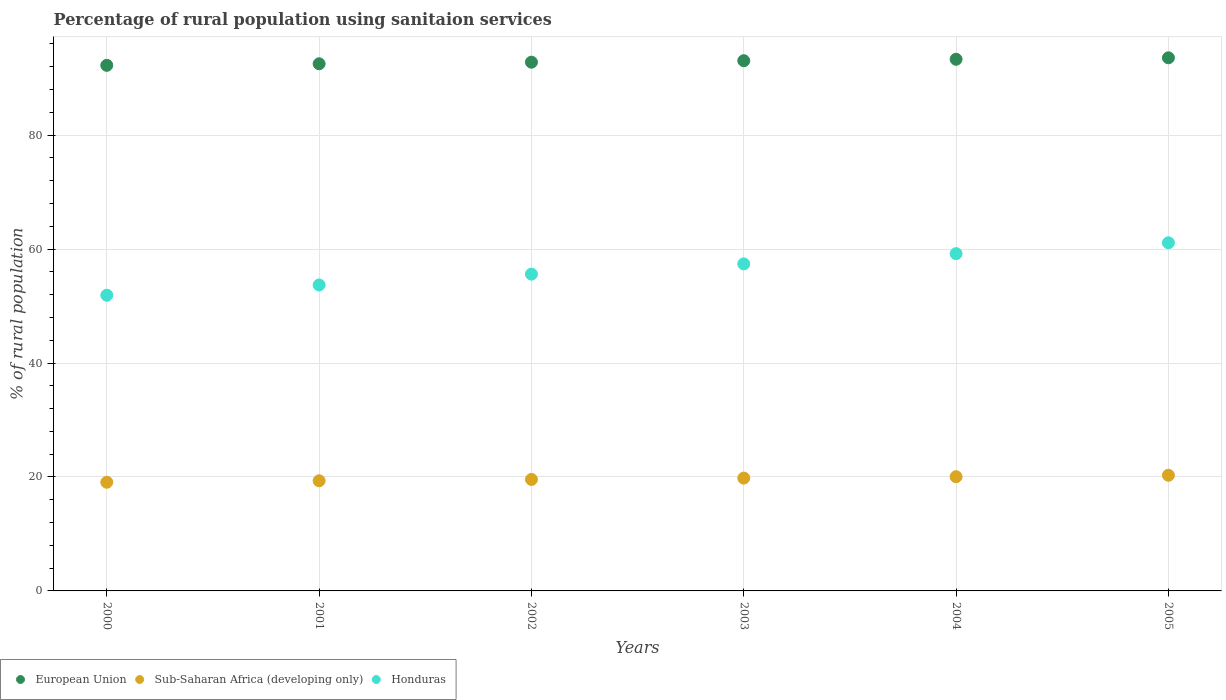What is the percentage of rural population using sanitaion services in Sub-Saharan Africa (developing only) in 2002?
Your response must be concise. 19.57. Across all years, what is the maximum percentage of rural population using sanitaion services in Sub-Saharan Africa (developing only)?
Your answer should be compact. 20.3. Across all years, what is the minimum percentage of rural population using sanitaion services in Sub-Saharan Africa (developing only)?
Keep it short and to the point. 19.08. In which year was the percentage of rural population using sanitaion services in European Union minimum?
Offer a very short reply. 2000. What is the total percentage of rural population using sanitaion services in European Union in the graph?
Make the answer very short. 557.52. What is the difference between the percentage of rural population using sanitaion services in European Union in 2000 and that in 2001?
Your answer should be very brief. -0.27. What is the difference between the percentage of rural population using sanitaion services in Sub-Saharan Africa (developing only) in 2003 and the percentage of rural population using sanitaion services in Honduras in 2001?
Offer a very short reply. -33.9. What is the average percentage of rural population using sanitaion services in European Union per year?
Give a very brief answer. 92.92. In the year 2000, what is the difference between the percentage of rural population using sanitaion services in Sub-Saharan Africa (developing only) and percentage of rural population using sanitaion services in Honduras?
Ensure brevity in your answer.  -32.82. In how many years, is the percentage of rural population using sanitaion services in Honduras greater than 56 %?
Keep it short and to the point. 3. What is the ratio of the percentage of rural population using sanitaion services in European Union in 2003 to that in 2005?
Offer a terse response. 0.99. Is the percentage of rural population using sanitaion services in Honduras in 2001 less than that in 2002?
Your response must be concise. Yes. What is the difference between the highest and the second highest percentage of rural population using sanitaion services in Sub-Saharan Africa (developing only)?
Your answer should be very brief. 0.25. What is the difference between the highest and the lowest percentage of rural population using sanitaion services in Sub-Saharan Africa (developing only)?
Your answer should be compact. 1.22. Is the sum of the percentage of rural population using sanitaion services in European Union in 2001 and 2003 greater than the maximum percentage of rural population using sanitaion services in Honduras across all years?
Offer a terse response. Yes. Does the percentage of rural population using sanitaion services in European Union monotonically increase over the years?
Make the answer very short. Yes. Is the percentage of rural population using sanitaion services in Sub-Saharan Africa (developing only) strictly less than the percentage of rural population using sanitaion services in Honduras over the years?
Provide a succinct answer. Yes. How many years are there in the graph?
Make the answer very short. 6. Does the graph contain any zero values?
Give a very brief answer. No. Where does the legend appear in the graph?
Make the answer very short. Bottom left. How many legend labels are there?
Your response must be concise. 3. How are the legend labels stacked?
Offer a very short reply. Horizontal. What is the title of the graph?
Keep it short and to the point. Percentage of rural population using sanitaion services. Does "Ghana" appear as one of the legend labels in the graph?
Offer a terse response. No. What is the label or title of the Y-axis?
Provide a short and direct response. % of rural population. What is the % of rural population in European Union in 2000?
Make the answer very short. 92.25. What is the % of rural population in Sub-Saharan Africa (developing only) in 2000?
Offer a terse response. 19.08. What is the % of rural population in Honduras in 2000?
Ensure brevity in your answer.  51.9. What is the % of rural population in European Union in 2001?
Provide a succinct answer. 92.52. What is the % of rural population of Sub-Saharan Africa (developing only) in 2001?
Ensure brevity in your answer.  19.33. What is the % of rural population in Honduras in 2001?
Your answer should be compact. 53.7. What is the % of rural population in European Union in 2002?
Your answer should be very brief. 92.8. What is the % of rural population of Sub-Saharan Africa (developing only) in 2002?
Keep it short and to the point. 19.57. What is the % of rural population in Honduras in 2002?
Keep it short and to the point. 55.6. What is the % of rural population of European Union in 2003?
Ensure brevity in your answer.  93.06. What is the % of rural population in Sub-Saharan Africa (developing only) in 2003?
Your response must be concise. 19.8. What is the % of rural population of Honduras in 2003?
Provide a short and direct response. 57.4. What is the % of rural population in European Union in 2004?
Provide a short and direct response. 93.31. What is the % of rural population in Sub-Saharan Africa (developing only) in 2004?
Offer a terse response. 20.04. What is the % of rural population of Honduras in 2004?
Provide a succinct answer. 59.2. What is the % of rural population of European Union in 2005?
Ensure brevity in your answer.  93.57. What is the % of rural population in Sub-Saharan Africa (developing only) in 2005?
Make the answer very short. 20.3. What is the % of rural population of Honduras in 2005?
Your answer should be very brief. 61.1. Across all years, what is the maximum % of rural population of European Union?
Give a very brief answer. 93.57. Across all years, what is the maximum % of rural population in Sub-Saharan Africa (developing only)?
Provide a succinct answer. 20.3. Across all years, what is the maximum % of rural population in Honduras?
Offer a very short reply. 61.1. Across all years, what is the minimum % of rural population of European Union?
Offer a terse response. 92.25. Across all years, what is the minimum % of rural population of Sub-Saharan Africa (developing only)?
Provide a succinct answer. 19.08. Across all years, what is the minimum % of rural population in Honduras?
Ensure brevity in your answer.  51.9. What is the total % of rural population of European Union in the graph?
Your answer should be compact. 557.52. What is the total % of rural population of Sub-Saharan Africa (developing only) in the graph?
Offer a terse response. 118.12. What is the total % of rural population in Honduras in the graph?
Provide a short and direct response. 338.9. What is the difference between the % of rural population of European Union in 2000 and that in 2001?
Provide a short and direct response. -0.27. What is the difference between the % of rural population in Sub-Saharan Africa (developing only) in 2000 and that in 2001?
Make the answer very short. -0.26. What is the difference between the % of rural population of European Union in 2000 and that in 2002?
Give a very brief answer. -0.55. What is the difference between the % of rural population of Sub-Saharan Africa (developing only) in 2000 and that in 2002?
Provide a succinct answer. -0.49. What is the difference between the % of rural population of European Union in 2000 and that in 2003?
Give a very brief answer. -0.81. What is the difference between the % of rural population of Sub-Saharan Africa (developing only) in 2000 and that in 2003?
Your response must be concise. -0.73. What is the difference between the % of rural population of Honduras in 2000 and that in 2003?
Offer a terse response. -5.5. What is the difference between the % of rural population in European Union in 2000 and that in 2004?
Your answer should be compact. -1.06. What is the difference between the % of rural population of Sub-Saharan Africa (developing only) in 2000 and that in 2004?
Ensure brevity in your answer.  -0.97. What is the difference between the % of rural population in Honduras in 2000 and that in 2004?
Offer a terse response. -7.3. What is the difference between the % of rural population in European Union in 2000 and that in 2005?
Your answer should be compact. -1.32. What is the difference between the % of rural population of Sub-Saharan Africa (developing only) in 2000 and that in 2005?
Offer a terse response. -1.22. What is the difference between the % of rural population of European Union in 2001 and that in 2002?
Your answer should be compact. -0.28. What is the difference between the % of rural population of Sub-Saharan Africa (developing only) in 2001 and that in 2002?
Provide a short and direct response. -0.23. What is the difference between the % of rural population of Honduras in 2001 and that in 2002?
Keep it short and to the point. -1.9. What is the difference between the % of rural population in European Union in 2001 and that in 2003?
Make the answer very short. -0.54. What is the difference between the % of rural population in Sub-Saharan Africa (developing only) in 2001 and that in 2003?
Your answer should be compact. -0.47. What is the difference between the % of rural population in Honduras in 2001 and that in 2003?
Ensure brevity in your answer.  -3.7. What is the difference between the % of rural population in European Union in 2001 and that in 2004?
Ensure brevity in your answer.  -0.79. What is the difference between the % of rural population of Sub-Saharan Africa (developing only) in 2001 and that in 2004?
Offer a terse response. -0.71. What is the difference between the % of rural population of European Union in 2001 and that in 2005?
Make the answer very short. -1.05. What is the difference between the % of rural population of Sub-Saharan Africa (developing only) in 2001 and that in 2005?
Give a very brief answer. -0.96. What is the difference between the % of rural population in Honduras in 2001 and that in 2005?
Your answer should be compact. -7.4. What is the difference between the % of rural population of European Union in 2002 and that in 2003?
Give a very brief answer. -0.26. What is the difference between the % of rural population in Sub-Saharan Africa (developing only) in 2002 and that in 2003?
Offer a terse response. -0.23. What is the difference between the % of rural population of Honduras in 2002 and that in 2003?
Your response must be concise. -1.8. What is the difference between the % of rural population of European Union in 2002 and that in 2004?
Ensure brevity in your answer.  -0.51. What is the difference between the % of rural population of Sub-Saharan Africa (developing only) in 2002 and that in 2004?
Give a very brief answer. -0.47. What is the difference between the % of rural population in Honduras in 2002 and that in 2004?
Your response must be concise. -3.6. What is the difference between the % of rural population of European Union in 2002 and that in 2005?
Offer a terse response. -0.77. What is the difference between the % of rural population of Sub-Saharan Africa (developing only) in 2002 and that in 2005?
Provide a succinct answer. -0.73. What is the difference between the % of rural population of European Union in 2003 and that in 2004?
Make the answer very short. -0.25. What is the difference between the % of rural population of Sub-Saharan Africa (developing only) in 2003 and that in 2004?
Make the answer very short. -0.24. What is the difference between the % of rural population in European Union in 2003 and that in 2005?
Your answer should be very brief. -0.51. What is the difference between the % of rural population of Sub-Saharan Africa (developing only) in 2003 and that in 2005?
Offer a very short reply. -0.5. What is the difference between the % of rural population in European Union in 2004 and that in 2005?
Provide a short and direct response. -0.26. What is the difference between the % of rural population in Sub-Saharan Africa (developing only) in 2004 and that in 2005?
Give a very brief answer. -0.26. What is the difference between the % of rural population of European Union in 2000 and the % of rural population of Sub-Saharan Africa (developing only) in 2001?
Give a very brief answer. 72.92. What is the difference between the % of rural population of European Union in 2000 and the % of rural population of Honduras in 2001?
Provide a short and direct response. 38.55. What is the difference between the % of rural population in Sub-Saharan Africa (developing only) in 2000 and the % of rural population in Honduras in 2001?
Keep it short and to the point. -34.62. What is the difference between the % of rural population in European Union in 2000 and the % of rural population in Sub-Saharan Africa (developing only) in 2002?
Your response must be concise. 72.68. What is the difference between the % of rural population of European Union in 2000 and the % of rural population of Honduras in 2002?
Provide a succinct answer. 36.65. What is the difference between the % of rural population of Sub-Saharan Africa (developing only) in 2000 and the % of rural population of Honduras in 2002?
Ensure brevity in your answer.  -36.52. What is the difference between the % of rural population of European Union in 2000 and the % of rural population of Sub-Saharan Africa (developing only) in 2003?
Your answer should be very brief. 72.45. What is the difference between the % of rural population of European Union in 2000 and the % of rural population of Honduras in 2003?
Your answer should be compact. 34.85. What is the difference between the % of rural population in Sub-Saharan Africa (developing only) in 2000 and the % of rural population in Honduras in 2003?
Your answer should be very brief. -38.32. What is the difference between the % of rural population in European Union in 2000 and the % of rural population in Sub-Saharan Africa (developing only) in 2004?
Your response must be concise. 72.21. What is the difference between the % of rural population of European Union in 2000 and the % of rural population of Honduras in 2004?
Provide a short and direct response. 33.05. What is the difference between the % of rural population of Sub-Saharan Africa (developing only) in 2000 and the % of rural population of Honduras in 2004?
Your response must be concise. -40.12. What is the difference between the % of rural population in European Union in 2000 and the % of rural population in Sub-Saharan Africa (developing only) in 2005?
Make the answer very short. 71.95. What is the difference between the % of rural population in European Union in 2000 and the % of rural population in Honduras in 2005?
Keep it short and to the point. 31.15. What is the difference between the % of rural population of Sub-Saharan Africa (developing only) in 2000 and the % of rural population of Honduras in 2005?
Offer a terse response. -42.02. What is the difference between the % of rural population of European Union in 2001 and the % of rural population of Sub-Saharan Africa (developing only) in 2002?
Make the answer very short. 72.95. What is the difference between the % of rural population of European Union in 2001 and the % of rural population of Honduras in 2002?
Provide a short and direct response. 36.92. What is the difference between the % of rural population of Sub-Saharan Africa (developing only) in 2001 and the % of rural population of Honduras in 2002?
Your answer should be compact. -36.27. What is the difference between the % of rural population in European Union in 2001 and the % of rural population in Sub-Saharan Africa (developing only) in 2003?
Offer a terse response. 72.72. What is the difference between the % of rural population of European Union in 2001 and the % of rural population of Honduras in 2003?
Give a very brief answer. 35.12. What is the difference between the % of rural population in Sub-Saharan Africa (developing only) in 2001 and the % of rural population in Honduras in 2003?
Your response must be concise. -38.07. What is the difference between the % of rural population in European Union in 2001 and the % of rural population in Sub-Saharan Africa (developing only) in 2004?
Your response must be concise. 72.48. What is the difference between the % of rural population in European Union in 2001 and the % of rural population in Honduras in 2004?
Offer a terse response. 33.32. What is the difference between the % of rural population in Sub-Saharan Africa (developing only) in 2001 and the % of rural population in Honduras in 2004?
Keep it short and to the point. -39.87. What is the difference between the % of rural population in European Union in 2001 and the % of rural population in Sub-Saharan Africa (developing only) in 2005?
Your answer should be compact. 72.22. What is the difference between the % of rural population in European Union in 2001 and the % of rural population in Honduras in 2005?
Offer a very short reply. 31.42. What is the difference between the % of rural population in Sub-Saharan Africa (developing only) in 2001 and the % of rural population in Honduras in 2005?
Your answer should be very brief. -41.77. What is the difference between the % of rural population of European Union in 2002 and the % of rural population of Sub-Saharan Africa (developing only) in 2003?
Keep it short and to the point. 73. What is the difference between the % of rural population in European Union in 2002 and the % of rural population in Honduras in 2003?
Your answer should be compact. 35.4. What is the difference between the % of rural population in Sub-Saharan Africa (developing only) in 2002 and the % of rural population in Honduras in 2003?
Offer a very short reply. -37.83. What is the difference between the % of rural population in European Union in 2002 and the % of rural population in Sub-Saharan Africa (developing only) in 2004?
Provide a short and direct response. 72.76. What is the difference between the % of rural population in European Union in 2002 and the % of rural population in Honduras in 2004?
Keep it short and to the point. 33.6. What is the difference between the % of rural population in Sub-Saharan Africa (developing only) in 2002 and the % of rural population in Honduras in 2004?
Provide a succinct answer. -39.63. What is the difference between the % of rural population of European Union in 2002 and the % of rural population of Sub-Saharan Africa (developing only) in 2005?
Your response must be concise. 72.5. What is the difference between the % of rural population in European Union in 2002 and the % of rural population in Honduras in 2005?
Ensure brevity in your answer.  31.7. What is the difference between the % of rural population of Sub-Saharan Africa (developing only) in 2002 and the % of rural population of Honduras in 2005?
Offer a very short reply. -41.53. What is the difference between the % of rural population in European Union in 2003 and the % of rural population in Sub-Saharan Africa (developing only) in 2004?
Keep it short and to the point. 73.02. What is the difference between the % of rural population in European Union in 2003 and the % of rural population in Honduras in 2004?
Your response must be concise. 33.86. What is the difference between the % of rural population in Sub-Saharan Africa (developing only) in 2003 and the % of rural population in Honduras in 2004?
Provide a short and direct response. -39.4. What is the difference between the % of rural population of European Union in 2003 and the % of rural population of Sub-Saharan Africa (developing only) in 2005?
Offer a terse response. 72.76. What is the difference between the % of rural population in European Union in 2003 and the % of rural population in Honduras in 2005?
Keep it short and to the point. 31.96. What is the difference between the % of rural population in Sub-Saharan Africa (developing only) in 2003 and the % of rural population in Honduras in 2005?
Offer a very short reply. -41.3. What is the difference between the % of rural population of European Union in 2004 and the % of rural population of Sub-Saharan Africa (developing only) in 2005?
Provide a succinct answer. 73.02. What is the difference between the % of rural population in European Union in 2004 and the % of rural population in Honduras in 2005?
Your answer should be compact. 32.21. What is the difference between the % of rural population of Sub-Saharan Africa (developing only) in 2004 and the % of rural population of Honduras in 2005?
Your answer should be compact. -41.06. What is the average % of rural population of European Union per year?
Offer a very short reply. 92.92. What is the average % of rural population of Sub-Saharan Africa (developing only) per year?
Provide a succinct answer. 19.69. What is the average % of rural population of Honduras per year?
Keep it short and to the point. 56.48. In the year 2000, what is the difference between the % of rural population of European Union and % of rural population of Sub-Saharan Africa (developing only)?
Offer a terse response. 73.17. In the year 2000, what is the difference between the % of rural population in European Union and % of rural population in Honduras?
Your answer should be very brief. 40.35. In the year 2000, what is the difference between the % of rural population of Sub-Saharan Africa (developing only) and % of rural population of Honduras?
Your response must be concise. -32.82. In the year 2001, what is the difference between the % of rural population of European Union and % of rural population of Sub-Saharan Africa (developing only)?
Provide a succinct answer. 73.19. In the year 2001, what is the difference between the % of rural population in European Union and % of rural population in Honduras?
Your answer should be very brief. 38.82. In the year 2001, what is the difference between the % of rural population of Sub-Saharan Africa (developing only) and % of rural population of Honduras?
Keep it short and to the point. -34.37. In the year 2002, what is the difference between the % of rural population of European Union and % of rural population of Sub-Saharan Africa (developing only)?
Your response must be concise. 73.23. In the year 2002, what is the difference between the % of rural population of European Union and % of rural population of Honduras?
Your answer should be compact. 37.2. In the year 2002, what is the difference between the % of rural population in Sub-Saharan Africa (developing only) and % of rural population in Honduras?
Ensure brevity in your answer.  -36.03. In the year 2003, what is the difference between the % of rural population in European Union and % of rural population in Sub-Saharan Africa (developing only)?
Provide a succinct answer. 73.26. In the year 2003, what is the difference between the % of rural population of European Union and % of rural population of Honduras?
Offer a very short reply. 35.66. In the year 2003, what is the difference between the % of rural population of Sub-Saharan Africa (developing only) and % of rural population of Honduras?
Offer a terse response. -37.6. In the year 2004, what is the difference between the % of rural population of European Union and % of rural population of Sub-Saharan Africa (developing only)?
Your answer should be compact. 73.27. In the year 2004, what is the difference between the % of rural population in European Union and % of rural population in Honduras?
Offer a very short reply. 34.11. In the year 2004, what is the difference between the % of rural population of Sub-Saharan Africa (developing only) and % of rural population of Honduras?
Give a very brief answer. -39.16. In the year 2005, what is the difference between the % of rural population in European Union and % of rural population in Sub-Saharan Africa (developing only)?
Keep it short and to the point. 73.28. In the year 2005, what is the difference between the % of rural population in European Union and % of rural population in Honduras?
Your answer should be very brief. 32.47. In the year 2005, what is the difference between the % of rural population in Sub-Saharan Africa (developing only) and % of rural population in Honduras?
Provide a short and direct response. -40.8. What is the ratio of the % of rural population in Sub-Saharan Africa (developing only) in 2000 to that in 2001?
Offer a very short reply. 0.99. What is the ratio of the % of rural population of Honduras in 2000 to that in 2001?
Your answer should be compact. 0.97. What is the ratio of the % of rural population in Sub-Saharan Africa (developing only) in 2000 to that in 2002?
Ensure brevity in your answer.  0.97. What is the ratio of the % of rural population of Honduras in 2000 to that in 2002?
Offer a terse response. 0.93. What is the ratio of the % of rural population of Sub-Saharan Africa (developing only) in 2000 to that in 2003?
Make the answer very short. 0.96. What is the ratio of the % of rural population of Honduras in 2000 to that in 2003?
Make the answer very short. 0.9. What is the ratio of the % of rural population in Sub-Saharan Africa (developing only) in 2000 to that in 2004?
Your answer should be compact. 0.95. What is the ratio of the % of rural population in Honduras in 2000 to that in 2004?
Provide a succinct answer. 0.88. What is the ratio of the % of rural population in European Union in 2000 to that in 2005?
Keep it short and to the point. 0.99. What is the ratio of the % of rural population in Sub-Saharan Africa (developing only) in 2000 to that in 2005?
Your answer should be compact. 0.94. What is the ratio of the % of rural population in Honduras in 2000 to that in 2005?
Offer a terse response. 0.85. What is the ratio of the % of rural population in European Union in 2001 to that in 2002?
Offer a terse response. 1. What is the ratio of the % of rural population in Honduras in 2001 to that in 2002?
Your answer should be compact. 0.97. What is the ratio of the % of rural population in European Union in 2001 to that in 2003?
Your answer should be very brief. 0.99. What is the ratio of the % of rural population of Sub-Saharan Africa (developing only) in 2001 to that in 2003?
Offer a very short reply. 0.98. What is the ratio of the % of rural population in Honduras in 2001 to that in 2003?
Give a very brief answer. 0.94. What is the ratio of the % of rural population of European Union in 2001 to that in 2004?
Provide a short and direct response. 0.99. What is the ratio of the % of rural population of Sub-Saharan Africa (developing only) in 2001 to that in 2004?
Give a very brief answer. 0.96. What is the ratio of the % of rural population of Honduras in 2001 to that in 2004?
Provide a succinct answer. 0.91. What is the ratio of the % of rural population of Sub-Saharan Africa (developing only) in 2001 to that in 2005?
Your answer should be compact. 0.95. What is the ratio of the % of rural population of Honduras in 2001 to that in 2005?
Offer a very short reply. 0.88. What is the ratio of the % of rural population of Honduras in 2002 to that in 2003?
Keep it short and to the point. 0.97. What is the ratio of the % of rural population of European Union in 2002 to that in 2004?
Keep it short and to the point. 0.99. What is the ratio of the % of rural population of Sub-Saharan Africa (developing only) in 2002 to that in 2004?
Give a very brief answer. 0.98. What is the ratio of the % of rural population in Honduras in 2002 to that in 2004?
Provide a short and direct response. 0.94. What is the ratio of the % of rural population of European Union in 2002 to that in 2005?
Offer a very short reply. 0.99. What is the ratio of the % of rural population of Sub-Saharan Africa (developing only) in 2002 to that in 2005?
Your response must be concise. 0.96. What is the ratio of the % of rural population of Honduras in 2002 to that in 2005?
Give a very brief answer. 0.91. What is the ratio of the % of rural population of Honduras in 2003 to that in 2004?
Your answer should be compact. 0.97. What is the ratio of the % of rural population in European Union in 2003 to that in 2005?
Your answer should be very brief. 0.99. What is the ratio of the % of rural population of Sub-Saharan Africa (developing only) in 2003 to that in 2005?
Provide a short and direct response. 0.98. What is the ratio of the % of rural population in Honduras in 2003 to that in 2005?
Provide a succinct answer. 0.94. What is the ratio of the % of rural population in European Union in 2004 to that in 2005?
Your answer should be compact. 1. What is the ratio of the % of rural population in Sub-Saharan Africa (developing only) in 2004 to that in 2005?
Provide a succinct answer. 0.99. What is the ratio of the % of rural population in Honduras in 2004 to that in 2005?
Offer a very short reply. 0.97. What is the difference between the highest and the second highest % of rural population of European Union?
Your response must be concise. 0.26. What is the difference between the highest and the second highest % of rural population of Sub-Saharan Africa (developing only)?
Provide a short and direct response. 0.26. What is the difference between the highest and the second highest % of rural population of Honduras?
Offer a very short reply. 1.9. What is the difference between the highest and the lowest % of rural population of European Union?
Make the answer very short. 1.32. What is the difference between the highest and the lowest % of rural population of Sub-Saharan Africa (developing only)?
Give a very brief answer. 1.22. What is the difference between the highest and the lowest % of rural population of Honduras?
Keep it short and to the point. 9.2. 